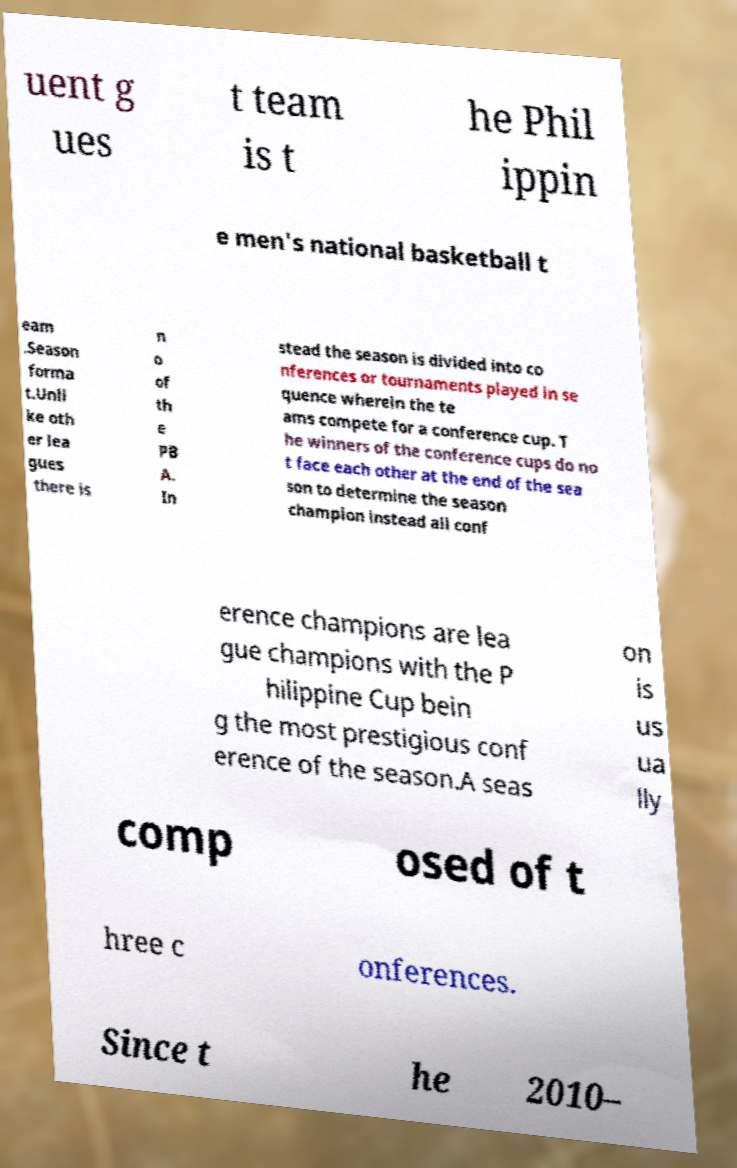I need the written content from this picture converted into text. Can you do that? uent g ues t team is t he Phil ippin e men's national basketball t eam .Season forma t.Unli ke oth er lea gues there is n o of th e PB A. In stead the season is divided into co nferences or tournaments played in se quence wherein the te ams compete for a conference cup. T he winners of the conference cups do no t face each other at the end of the sea son to determine the season champion instead all conf erence champions are lea gue champions with the P hilippine Cup bein g the most prestigious conf erence of the season.A seas on is us ua lly comp osed of t hree c onferences. Since t he 2010– 